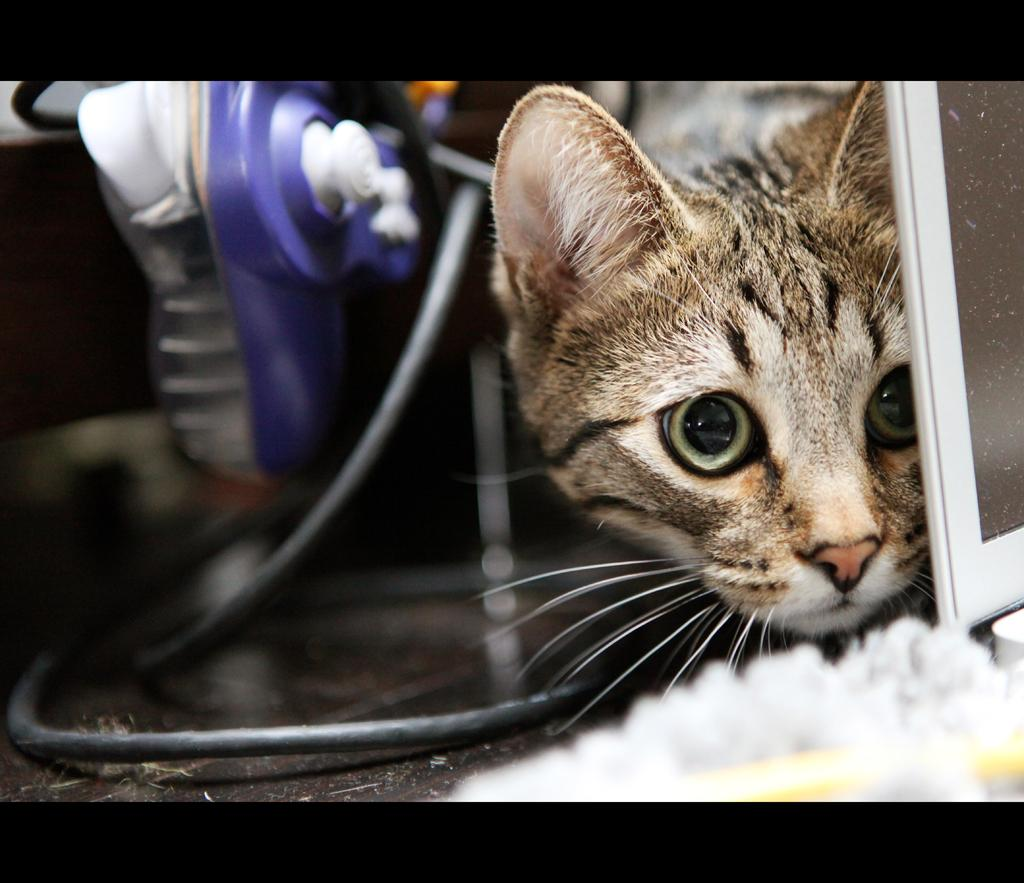What type of animal is present in the image? There is a cat in the image. What object can be seen running through the image? There is a wire in the image. What is located near the wire in the image? There is a device beside the wire in the image. What type of button can be seen on the cat's collar in the image? There is no button visible on the cat's collar in the image. What is the cat using the yarn for in the image? There is no yarn present in the image, and the cat is not shown using any yarn. 